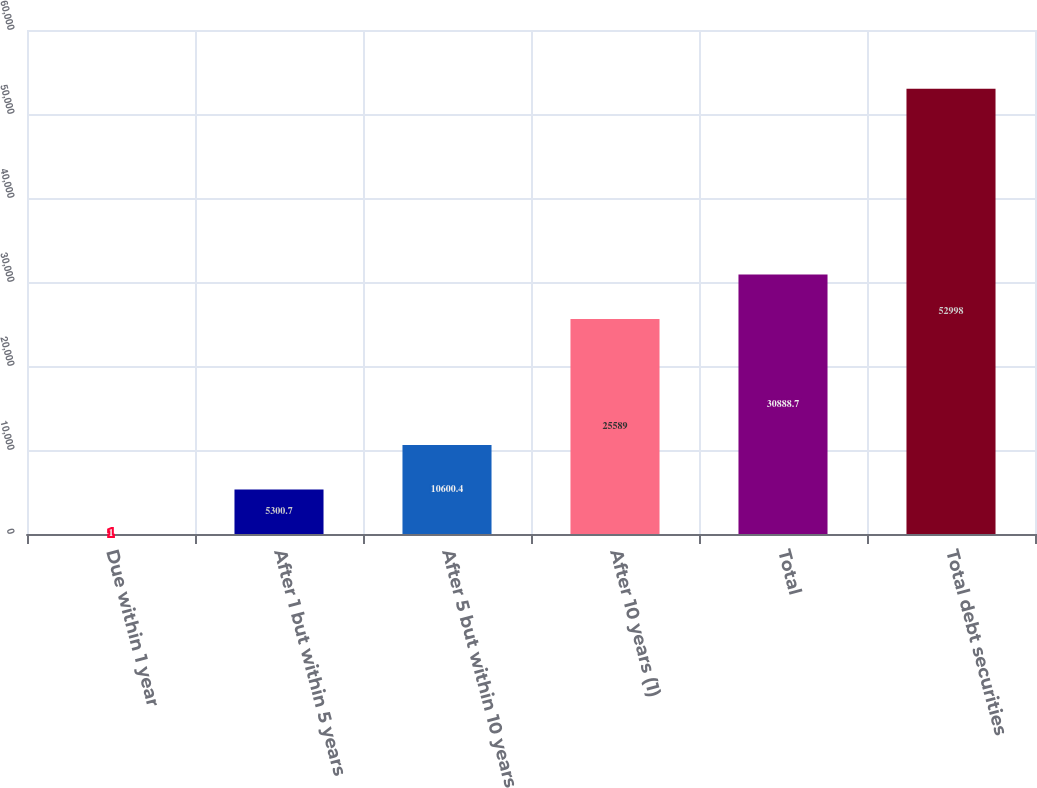Convert chart. <chart><loc_0><loc_0><loc_500><loc_500><bar_chart><fcel>Due within 1 year<fcel>After 1 but within 5 years<fcel>After 5 but within 10 years<fcel>After 10 years (1)<fcel>Total<fcel>Total debt securities<nl><fcel>1<fcel>5300.7<fcel>10600.4<fcel>25589<fcel>30888.7<fcel>52998<nl></chart> 